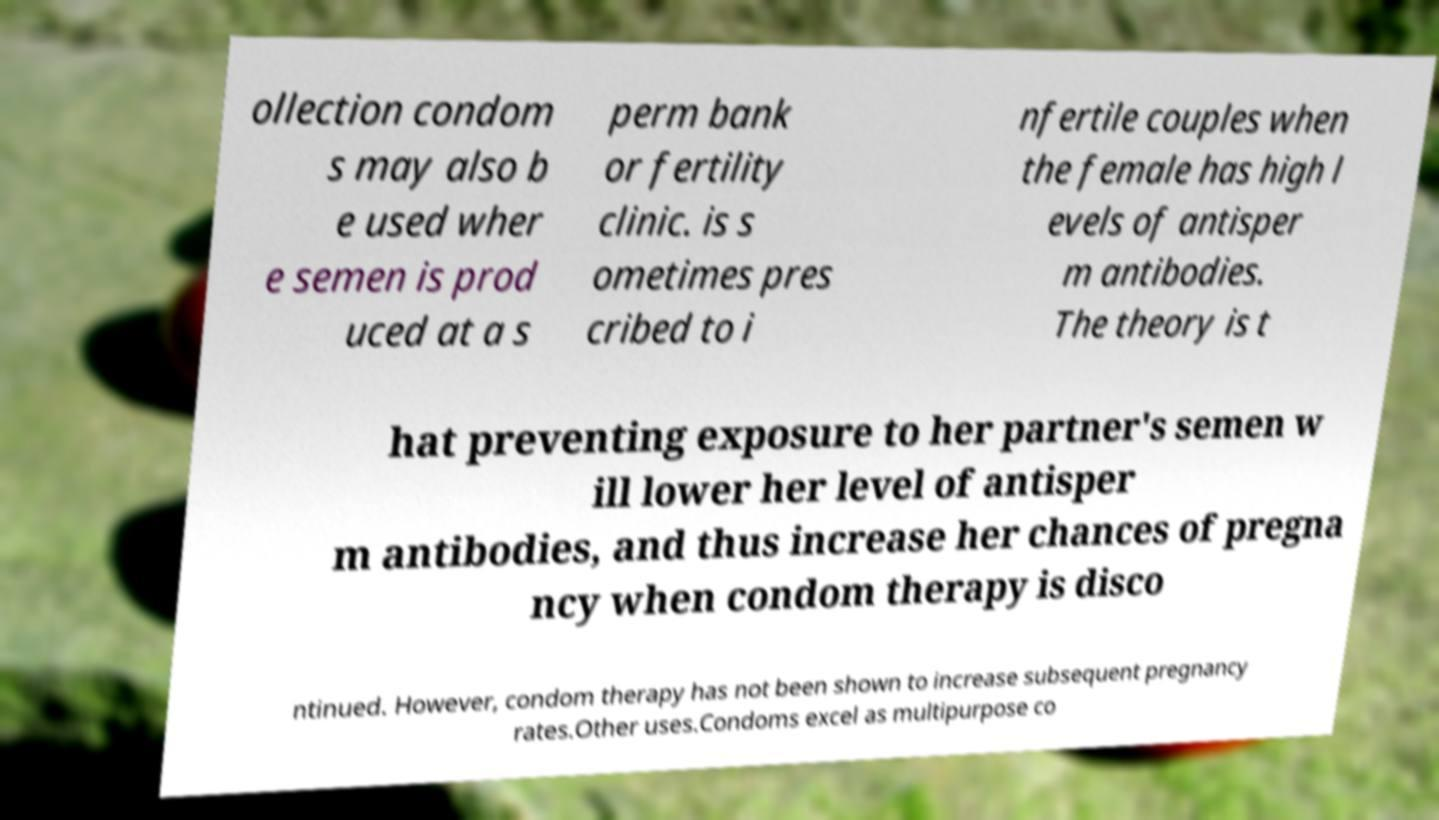What messages or text are displayed in this image? I need them in a readable, typed format. ollection condom s may also b e used wher e semen is prod uced at a s perm bank or fertility clinic. is s ometimes pres cribed to i nfertile couples when the female has high l evels of antisper m antibodies. The theory is t hat preventing exposure to her partner's semen w ill lower her level of antisper m antibodies, and thus increase her chances of pregna ncy when condom therapy is disco ntinued. However, condom therapy has not been shown to increase subsequent pregnancy rates.Other uses.Condoms excel as multipurpose co 